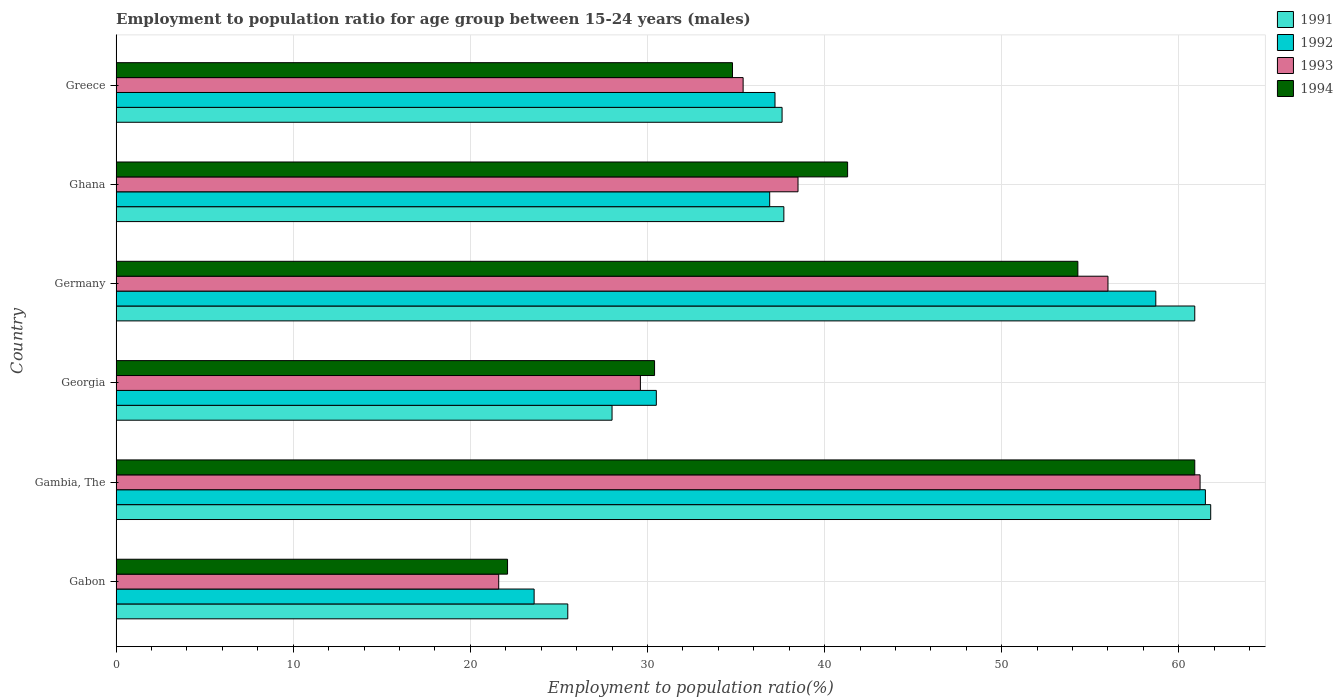How many different coloured bars are there?
Make the answer very short. 4. Are the number of bars per tick equal to the number of legend labels?
Your answer should be compact. Yes. Are the number of bars on each tick of the Y-axis equal?
Provide a succinct answer. Yes. What is the label of the 2nd group of bars from the top?
Offer a terse response. Ghana. In how many cases, is the number of bars for a given country not equal to the number of legend labels?
Keep it short and to the point. 0. What is the employment to population ratio in 1991 in Ghana?
Give a very brief answer. 37.7. Across all countries, what is the maximum employment to population ratio in 1991?
Ensure brevity in your answer.  61.8. Across all countries, what is the minimum employment to population ratio in 1991?
Provide a succinct answer. 25.5. In which country was the employment to population ratio in 1993 maximum?
Your answer should be very brief. Gambia, The. In which country was the employment to population ratio in 1992 minimum?
Provide a succinct answer. Gabon. What is the total employment to population ratio in 1994 in the graph?
Keep it short and to the point. 243.8. What is the difference between the employment to population ratio in 1994 in Gambia, The and that in Germany?
Provide a succinct answer. 6.6. What is the difference between the employment to population ratio in 1992 in Gambia, The and the employment to population ratio in 1994 in Gabon?
Keep it short and to the point. 39.4. What is the average employment to population ratio in 1994 per country?
Give a very brief answer. 40.63. What is the difference between the employment to population ratio in 1991 and employment to population ratio in 1993 in Germany?
Provide a succinct answer. 4.9. In how many countries, is the employment to population ratio in 1992 greater than 44 %?
Your response must be concise. 2. What is the ratio of the employment to population ratio in 1992 in Gabon to that in Gambia, The?
Offer a very short reply. 0.38. Is the difference between the employment to population ratio in 1991 in Gambia, The and Greece greater than the difference between the employment to population ratio in 1993 in Gambia, The and Greece?
Provide a short and direct response. No. What is the difference between the highest and the second highest employment to population ratio in 1991?
Offer a terse response. 0.9. What is the difference between the highest and the lowest employment to population ratio in 1992?
Your answer should be very brief. 37.9. Is it the case that in every country, the sum of the employment to population ratio in 1991 and employment to population ratio in 1994 is greater than the sum of employment to population ratio in 1992 and employment to population ratio in 1993?
Keep it short and to the point. No. How many countries are there in the graph?
Ensure brevity in your answer.  6. What is the difference between two consecutive major ticks on the X-axis?
Your answer should be compact. 10. Are the values on the major ticks of X-axis written in scientific E-notation?
Your response must be concise. No. Does the graph contain any zero values?
Offer a very short reply. No. What is the title of the graph?
Your response must be concise. Employment to population ratio for age group between 15-24 years (males). Does "1997" appear as one of the legend labels in the graph?
Keep it short and to the point. No. What is the label or title of the Y-axis?
Provide a short and direct response. Country. What is the Employment to population ratio(%) of 1992 in Gabon?
Ensure brevity in your answer.  23.6. What is the Employment to population ratio(%) of 1993 in Gabon?
Offer a very short reply. 21.6. What is the Employment to population ratio(%) of 1994 in Gabon?
Provide a short and direct response. 22.1. What is the Employment to population ratio(%) of 1991 in Gambia, The?
Offer a very short reply. 61.8. What is the Employment to population ratio(%) of 1992 in Gambia, The?
Offer a terse response. 61.5. What is the Employment to population ratio(%) in 1993 in Gambia, The?
Your answer should be very brief. 61.2. What is the Employment to population ratio(%) of 1994 in Gambia, The?
Keep it short and to the point. 60.9. What is the Employment to population ratio(%) of 1991 in Georgia?
Give a very brief answer. 28. What is the Employment to population ratio(%) in 1992 in Georgia?
Give a very brief answer. 30.5. What is the Employment to population ratio(%) of 1993 in Georgia?
Give a very brief answer. 29.6. What is the Employment to population ratio(%) of 1994 in Georgia?
Keep it short and to the point. 30.4. What is the Employment to population ratio(%) in 1991 in Germany?
Ensure brevity in your answer.  60.9. What is the Employment to population ratio(%) in 1992 in Germany?
Your response must be concise. 58.7. What is the Employment to population ratio(%) of 1993 in Germany?
Your answer should be very brief. 56. What is the Employment to population ratio(%) in 1994 in Germany?
Offer a very short reply. 54.3. What is the Employment to population ratio(%) of 1991 in Ghana?
Provide a succinct answer. 37.7. What is the Employment to population ratio(%) of 1992 in Ghana?
Your answer should be compact. 36.9. What is the Employment to population ratio(%) of 1993 in Ghana?
Offer a very short reply. 38.5. What is the Employment to population ratio(%) in 1994 in Ghana?
Keep it short and to the point. 41.3. What is the Employment to population ratio(%) in 1991 in Greece?
Your answer should be compact. 37.6. What is the Employment to population ratio(%) of 1992 in Greece?
Your response must be concise. 37.2. What is the Employment to population ratio(%) in 1993 in Greece?
Give a very brief answer. 35.4. What is the Employment to population ratio(%) in 1994 in Greece?
Ensure brevity in your answer.  34.8. Across all countries, what is the maximum Employment to population ratio(%) of 1991?
Make the answer very short. 61.8. Across all countries, what is the maximum Employment to population ratio(%) in 1992?
Give a very brief answer. 61.5. Across all countries, what is the maximum Employment to population ratio(%) of 1993?
Ensure brevity in your answer.  61.2. Across all countries, what is the maximum Employment to population ratio(%) of 1994?
Provide a succinct answer. 60.9. Across all countries, what is the minimum Employment to population ratio(%) in 1991?
Give a very brief answer. 25.5. Across all countries, what is the minimum Employment to population ratio(%) in 1992?
Your answer should be very brief. 23.6. Across all countries, what is the minimum Employment to population ratio(%) in 1993?
Provide a succinct answer. 21.6. Across all countries, what is the minimum Employment to population ratio(%) in 1994?
Your answer should be compact. 22.1. What is the total Employment to population ratio(%) in 1991 in the graph?
Give a very brief answer. 251.5. What is the total Employment to population ratio(%) in 1992 in the graph?
Ensure brevity in your answer.  248.4. What is the total Employment to population ratio(%) in 1993 in the graph?
Make the answer very short. 242.3. What is the total Employment to population ratio(%) of 1994 in the graph?
Your response must be concise. 243.8. What is the difference between the Employment to population ratio(%) in 1991 in Gabon and that in Gambia, The?
Provide a succinct answer. -36.3. What is the difference between the Employment to population ratio(%) of 1992 in Gabon and that in Gambia, The?
Provide a short and direct response. -37.9. What is the difference between the Employment to population ratio(%) in 1993 in Gabon and that in Gambia, The?
Provide a succinct answer. -39.6. What is the difference between the Employment to population ratio(%) in 1994 in Gabon and that in Gambia, The?
Give a very brief answer. -38.8. What is the difference between the Employment to population ratio(%) in 1991 in Gabon and that in Georgia?
Provide a succinct answer. -2.5. What is the difference between the Employment to population ratio(%) of 1992 in Gabon and that in Georgia?
Offer a terse response. -6.9. What is the difference between the Employment to population ratio(%) of 1994 in Gabon and that in Georgia?
Provide a succinct answer. -8.3. What is the difference between the Employment to population ratio(%) in 1991 in Gabon and that in Germany?
Your answer should be compact. -35.4. What is the difference between the Employment to population ratio(%) of 1992 in Gabon and that in Germany?
Ensure brevity in your answer.  -35.1. What is the difference between the Employment to population ratio(%) in 1993 in Gabon and that in Germany?
Keep it short and to the point. -34.4. What is the difference between the Employment to population ratio(%) of 1994 in Gabon and that in Germany?
Provide a succinct answer. -32.2. What is the difference between the Employment to population ratio(%) of 1991 in Gabon and that in Ghana?
Give a very brief answer. -12.2. What is the difference between the Employment to population ratio(%) in 1992 in Gabon and that in Ghana?
Ensure brevity in your answer.  -13.3. What is the difference between the Employment to population ratio(%) of 1993 in Gabon and that in Ghana?
Offer a terse response. -16.9. What is the difference between the Employment to population ratio(%) in 1994 in Gabon and that in Ghana?
Provide a short and direct response. -19.2. What is the difference between the Employment to population ratio(%) of 1991 in Gabon and that in Greece?
Offer a very short reply. -12.1. What is the difference between the Employment to population ratio(%) in 1993 in Gabon and that in Greece?
Offer a very short reply. -13.8. What is the difference between the Employment to population ratio(%) in 1991 in Gambia, The and that in Georgia?
Offer a terse response. 33.8. What is the difference between the Employment to population ratio(%) in 1992 in Gambia, The and that in Georgia?
Your answer should be compact. 31. What is the difference between the Employment to population ratio(%) of 1993 in Gambia, The and that in Georgia?
Provide a succinct answer. 31.6. What is the difference between the Employment to population ratio(%) in 1994 in Gambia, The and that in Georgia?
Your answer should be compact. 30.5. What is the difference between the Employment to population ratio(%) of 1991 in Gambia, The and that in Ghana?
Offer a very short reply. 24.1. What is the difference between the Employment to population ratio(%) in 1992 in Gambia, The and that in Ghana?
Give a very brief answer. 24.6. What is the difference between the Employment to population ratio(%) of 1993 in Gambia, The and that in Ghana?
Give a very brief answer. 22.7. What is the difference between the Employment to population ratio(%) of 1994 in Gambia, The and that in Ghana?
Offer a terse response. 19.6. What is the difference between the Employment to population ratio(%) in 1991 in Gambia, The and that in Greece?
Provide a succinct answer. 24.2. What is the difference between the Employment to population ratio(%) of 1992 in Gambia, The and that in Greece?
Your answer should be very brief. 24.3. What is the difference between the Employment to population ratio(%) in 1993 in Gambia, The and that in Greece?
Ensure brevity in your answer.  25.8. What is the difference between the Employment to population ratio(%) in 1994 in Gambia, The and that in Greece?
Offer a very short reply. 26.1. What is the difference between the Employment to population ratio(%) in 1991 in Georgia and that in Germany?
Provide a succinct answer. -32.9. What is the difference between the Employment to population ratio(%) of 1992 in Georgia and that in Germany?
Offer a terse response. -28.2. What is the difference between the Employment to population ratio(%) of 1993 in Georgia and that in Germany?
Your response must be concise. -26.4. What is the difference between the Employment to population ratio(%) in 1994 in Georgia and that in Germany?
Make the answer very short. -23.9. What is the difference between the Employment to population ratio(%) of 1992 in Georgia and that in Ghana?
Offer a very short reply. -6.4. What is the difference between the Employment to population ratio(%) in 1993 in Georgia and that in Ghana?
Your response must be concise. -8.9. What is the difference between the Employment to population ratio(%) of 1991 in Georgia and that in Greece?
Keep it short and to the point. -9.6. What is the difference between the Employment to population ratio(%) of 1993 in Georgia and that in Greece?
Provide a succinct answer. -5.8. What is the difference between the Employment to population ratio(%) of 1994 in Georgia and that in Greece?
Your answer should be compact. -4.4. What is the difference between the Employment to population ratio(%) in 1991 in Germany and that in Ghana?
Your response must be concise. 23.2. What is the difference between the Employment to population ratio(%) in 1992 in Germany and that in Ghana?
Make the answer very short. 21.8. What is the difference between the Employment to population ratio(%) of 1993 in Germany and that in Ghana?
Your answer should be very brief. 17.5. What is the difference between the Employment to population ratio(%) of 1994 in Germany and that in Ghana?
Offer a very short reply. 13. What is the difference between the Employment to population ratio(%) in 1991 in Germany and that in Greece?
Your answer should be very brief. 23.3. What is the difference between the Employment to population ratio(%) of 1993 in Germany and that in Greece?
Offer a terse response. 20.6. What is the difference between the Employment to population ratio(%) in 1994 in Germany and that in Greece?
Offer a very short reply. 19.5. What is the difference between the Employment to population ratio(%) in 1991 in Ghana and that in Greece?
Give a very brief answer. 0.1. What is the difference between the Employment to population ratio(%) of 1992 in Ghana and that in Greece?
Provide a short and direct response. -0.3. What is the difference between the Employment to population ratio(%) in 1994 in Ghana and that in Greece?
Offer a very short reply. 6.5. What is the difference between the Employment to population ratio(%) of 1991 in Gabon and the Employment to population ratio(%) of 1992 in Gambia, The?
Your answer should be compact. -36. What is the difference between the Employment to population ratio(%) of 1991 in Gabon and the Employment to population ratio(%) of 1993 in Gambia, The?
Keep it short and to the point. -35.7. What is the difference between the Employment to population ratio(%) in 1991 in Gabon and the Employment to population ratio(%) in 1994 in Gambia, The?
Offer a terse response. -35.4. What is the difference between the Employment to population ratio(%) in 1992 in Gabon and the Employment to population ratio(%) in 1993 in Gambia, The?
Give a very brief answer. -37.6. What is the difference between the Employment to population ratio(%) in 1992 in Gabon and the Employment to population ratio(%) in 1994 in Gambia, The?
Keep it short and to the point. -37.3. What is the difference between the Employment to population ratio(%) of 1993 in Gabon and the Employment to population ratio(%) of 1994 in Gambia, The?
Make the answer very short. -39.3. What is the difference between the Employment to population ratio(%) in 1992 in Gabon and the Employment to population ratio(%) in 1994 in Georgia?
Keep it short and to the point. -6.8. What is the difference between the Employment to population ratio(%) of 1993 in Gabon and the Employment to population ratio(%) of 1994 in Georgia?
Your response must be concise. -8.8. What is the difference between the Employment to population ratio(%) in 1991 in Gabon and the Employment to population ratio(%) in 1992 in Germany?
Offer a very short reply. -33.2. What is the difference between the Employment to population ratio(%) in 1991 in Gabon and the Employment to population ratio(%) in 1993 in Germany?
Offer a terse response. -30.5. What is the difference between the Employment to population ratio(%) in 1991 in Gabon and the Employment to population ratio(%) in 1994 in Germany?
Provide a succinct answer. -28.8. What is the difference between the Employment to population ratio(%) in 1992 in Gabon and the Employment to population ratio(%) in 1993 in Germany?
Your response must be concise. -32.4. What is the difference between the Employment to population ratio(%) of 1992 in Gabon and the Employment to population ratio(%) of 1994 in Germany?
Offer a very short reply. -30.7. What is the difference between the Employment to population ratio(%) in 1993 in Gabon and the Employment to population ratio(%) in 1994 in Germany?
Offer a terse response. -32.7. What is the difference between the Employment to population ratio(%) of 1991 in Gabon and the Employment to population ratio(%) of 1993 in Ghana?
Your answer should be very brief. -13. What is the difference between the Employment to population ratio(%) in 1991 in Gabon and the Employment to population ratio(%) in 1994 in Ghana?
Ensure brevity in your answer.  -15.8. What is the difference between the Employment to population ratio(%) of 1992 in Gabon and the Employment to population ratio(%) of 1993 in Ghana?
Provide a short and direct response. -14.9. What is the difference between the Employment to population ratio(%) of 1992 in Gabon and the Employment to population ratio(%) of 1994 in Ghana?
Offer a terse response. -17.7. What is the difference between the Employment to population ratio(%) of 1993 in Gabon and the Employment to population ratio(%) of 1994 in Ghana?
Offer a very short reply. -19.7. What is the difference between the Employment to population ratio(%) in 1991 in Gabon and the Employment to population ratio(%) in 1992 in Greece?
Offer a very short reply. -11.7. What is the difference between the Employment to population ratio(%) in 1992 in Gabon and the Employment to population ratio(%) in 1993 in Greece?
Provide a succinct answer. -11.8. What is the difference between the Employment to population ratio(%) of 1992 in Gabon and the Employment to population ratio(%) of 1994 in Greece?
Make the answer very short. -11.2. What is the difference between the Employment to population ratio(%) of 1993 in Gabon and the Employment to population ratio(%) of 1994 in Greece?
Offer a very short reply. -13.2. What is the difference between the Employment to population ratio(%) in 1991 in Gambia, The and the Employment to population ratio(%) in 1992 in Georgia?
Offer a very short reply. 31.3. What is the difference between the Employment to population ratio(%) of 1991 in Gambia, The and the Employment to population ratio(%) of 1993 in Georgia?
Offer a terse response. 32.2. What is the difference between the Employment to population ratio(%) in 1991 in Gambia, The and the Employment to population ratio(%) in 1994 in Georgia?
Offer a very short reply. 31.4. What is the difference between the Employment to population ratio(%) in 1992 in Gambia, The and the Employment to population ratio(%) in 1993 in Georgia?
Ensure brevity in your answer.  31.9. What is the difference between the Employment to population ratio(%) of 1992 in Gambia, The and the Employment to population ratio(%) of 1994 in Georgia?
Your answer should be very brief. 31.1. What is the difference between the Employment to population ratio(%) of 1993 in Gambia, The and the Employment to population ratio(%) of 1994 in Georgia?
Provide a short and direct response. 30.8. What is the difference between the Employment to population ratio(%) of 1992 in Gambia, The and the Employment to population ratio(%) of 1994 in Germany?
Your answer should be compact. 7.2. What is the difference between the Employment to population ratio(%) of 1993 in Gambia, The and the Employment to population ratio(%) of 1994 in Germany?
Make the answer very short. 6.9. What is the difference between the Employment to population ratio(%) of 1991 in Gambia, The and the Employment to population ratio(%) of 1992 in Ghana?
Your answer should be compact. 24.9. What is the difference between the Employment to population ratio(%) of 1991 in Gambia, The and the Employment to population ratio(%) of 1993 in Ghana?
Ensure brevity in your answer.  23.3. What is the difference between the Employment to population ratio(%) in 1991 in Gambia, The and the Employment to population ratio(%) in 1994 in Ghana?
Make the answer very short. 20.5. What is the difference between the Employment to population ratio(%) in 1992 in Gambia, The and the Employment to population ratio(%) in 1993 in Ghana?
Give a very brief answer. 23. What is the difference between the Employment to population ratio(%) of 1992 in Gambia, The and the Employment to population ratio(%) of 1994 in Ghana?
Offer a terse response. 20.2. What is the difference between the Employment to population ratio(%) of 1991 in Gambia, The and the Employment to population ratio(%) of 1992 in Greece?
Offer a terse response. 24.6. What is the difference between the Employment to population ratio(%) of 1991 in Gambia, The and the Employment to population ratio(%) of 1993 in Greece?
Keep it short and to the point. 26.4. What is the difference between the Employment to population ratio(%) in 1991 in Gambia, The and the Employment to population ratio(%) in 1994 in Greece?
Your response must be concise. 27. What is the difference between the Employment to population ratio(%) of 1992 in Gambia, The and the Employment to population ratio(%) of 1993 in Greece?
Provide a short and direct response. 26.1. What is the difference between the Employment to population ratio(%) in 1992 in Gambia, The and the Employment to population ratio(%) in 1994 in Greece?
Your answer should be very brief. 26.7. What is the difference between the Employment to population ratio(%) in 1993 in Gambia, The and the Employment to population ratio(%) in 1994 in Greece?
Provide a succinct answer. 26.4. What is the difference between the Employment to population ratio(%) of 1991 in Georgia and the Employment to population ratio(%) of 1992 in Germany?
Make the answer very short. -30.7. What is the difference between the Employment to population ratio(%) in 1991 in Georgia and the Employment to population ratio(%) in 1993 in Germany?
Your answer should be very brief. -28. What is the difference between the Employment to population ratio(%) in 1991 in Georgia and the Employment to population ratio(%) in 1994 in Germany?
Keep it short and to the point. -26.3. What is the difference between the Employment to population ratio(%) in 1992 in Georgia and the Employment to population ratio(%) in 1993 in Germany?
Make the answer very short. -25.5. What is the difference between the Employment to population ratio(%) of 1992 in Georgia and the Employment to population ratio(%) of 1994 in Germany?
Offer a terse response. -23.8. What is the difference between the Employment to population ratio(%) in 1993 in Georgia and the Employment to population ratio(%) in 1994 in Germany?
Offer a very short reply. -24.7. What is the difference between the Employment to population ratio(%) of 1991 in Georgia and the Employment to population ratio(%) of 1992 in Ghana?
Offer a very short reply. -8.9. What is the difference between the Employment to population ratio(%) in 1991 in Georgia and the Employment to population ratio(%) in 1993 in Ghana?
Keep it short and to the point. -10.5. What is the difference between the Employment to population ratio(%) in 1993 in Georgia and the Employment to population ratio(%) in 1994 in Ghana?
Your answer should be very brief. -11.7. What is the difference between the Employment to population ratio(%) of 1991 in Georgia and the Employment to population ratio(%) of 1992 in Greece?
Provide a short and direct response. -9.2. What is the difference between the Employment to population ratio(%) in 1991 in Georgia and the Employment to population ratio(%) in 1994 in Greece?
Your answer should be very brief. -6.8. What is the difference between the Employment to population ratio(%) of 1992 in Georgia and the Employment to population ratio(%) of 1993 in Greece?
Offer a terse response. -4.9. What is the difference between the Employment to population ratio(%) of 1992 in Georgia and the Employment to population ratio(%) of 1994 in Greece?
Your answer should be compact. -4.3. What is the difference between the Employment to population ratio(%) in 1993 in Georgia and the Employment to population ratio(%) in 1994 in Greece?
Your response must be concise. -5.2. What is the difference between the Employment to population ratio(%) of 1991 in Germany and the Employment to population ratio(%) of 1993 in Ghana?
Make the answer very short. 22.4. What is the difference between the Employment to population ratio(%) in 1991 in Germany and the Employment to population ratio(%) in 1994 in Ghana?
Offer a very short reply. 19.6. What is the difference between the Employment to population ratio(%) of 1992 in Germany and the Employment to population ratio(%) of 1993 in Ghana?
Give a very brief answer. 20.2. What is the difference between the Employment to population ratio(%) of 1993 in Germany and the Employment to population ratio(%) of 1994 in Ghana?
Keep it short and to the point. 14.7. What is the difference between the Employment to population ratio(%) in 1991 in Germany and the Employment to population ratio(%) in 1992 in Greece?
Offer a terse response. 23.7. What is the difference between the Employment to population ratio(%) of 1991 in Germany and the Employment to population ratio(%) of 1993 in Greece?
Offer a terse response. 25.5. What is the difference between the Employment to population ratio(%) of 1991 in Germany and the Employment to population ratio(%) of 1994 in Greece?
Offer a terse response. 26.1. What is the difference between the Employment to population ratio(%) of 1992 in Germany and the Employment to population ratio(%) of 1993 in Greece?
Make the answer very short. 23.3. What is the difference between the Employment to population ratio(%) in 1992 in Germany and the Employment to population ratio(%) in 1994 in Greece?
Offer a terse response. 23.9. What is the difference between the Employment to population ratio(%) of 1993 in Germany and the Employment to population ratio(%) of 1994 in Greece?
Make the answer very short. 21.2. What is the difference between the Employment to population ratio(%) in 1991 in Ghana and the Employment to population ratio(%) in 1992 in Greece?
Ensure brevity in your answer.  0.5. What is the difference between the Employment to population ratio(%) of 1991 in Ghana and the Employment to population ratio(%) of 1993 in Greece?
Your response must be concise. 2.3. What is the difference between the Employment to population ratio(%) of 1992 in Ghana and the Employment to population ratio(%) of 1993 in Greece?
Provide a short and direct response. 1.5. What is the difference between the Employment to population ratio(%) of 1992 in Ghana and the Employment to population ratio(%) of 1994 in Greece?
Provide a succinct answer. 2.1. What is the difference between the Employment to population ratio(%) of 1993 in Ghana and the Employment to population ratio(%) of 1994 in Greece?
Ensure brevity in your answer.  3.7. What is the average Employment to population ratio(%) of 1991 per country?
Offer a very short reply. 41.92. What is the average Employment to population ratio(%) in 1992 per country?
Offer a terse response. 41.4. What is the average Employment to population ratio(%) of 1993 per country?
Provide a succinct answer. 40.38. What is the average Employment to population ratio(%) of 1994 per country?
Offer a terse response. 40.63. What is the difference between the Employment to population ratio(%) of 1991 and Employment to population ratio(%) of 1992 in Gabon?
Your answer should be compact. 1.9. What is the difference between the Employment to population ratio(%) of 1993 and Employment to population ratio(%) of 1994 in Gabon?
Your answer should be compact. -0.5. What is the difference between the Employment to population ratio(%) of 1991 and Employment to population ratio(%) of 1994 in Gambia, The?
Give a very brief answer. 0.9. What is the difference between the Employment to population ratio(%) of 1991 and Employment to population ratio(%) of 1992 in Georgia?
Offer a very short reply. -2.5. What is the difference between the Employment to population ratio(%) of 1992 and Employment to population ratio(%) of 1993 in Georgia?
Your answer should be very brief. 0.9. What is the difference between the Employment to population ratio(%) in 1992 and Employment to population ratio(%) in 1994 in Georgia?
Provide a succinct answer. 0.1. What is the difference between the Employment to population ratio(%) of 1991 and Employment to population ratio(%) of 1994 in Germany?
Your answer should be very brief. 6.6. What is the difference between the Employment to population ratio(%) in 1991 and Employment to population ratio(%) in 1992 in Ghana?
Provide a short and direct response. 0.8. What is the difference between the Employment to population ratio(%) of 1991 and Employment to population ratio(%) of 1993 in Ghana?
Offer a terse response. -0.8. What is the difference between the Employment to population ratio(%) in 1991 and Employment to population ratio(%) in 1994 in Ghana?
Offer a terse response. -3.6. What is the difference between the Employment to population ratio(%) in 1992 and Employment to population ratio(%) in 1993 in Ghana?
Offer a terse response. -1.6. What is the difference between the Employment to population ratio(%) in 1992 and Employment to population ratio(%) in 1994 in Ghana?
Ensure brevity in your answer.  -4.4. What is the difference between the Employment to population ratio(%) in 1991 and Employment to population ratio(%) in 1992 in Greece?
Offer a terse response. 0.4. What is the difference between the Employment to population ratio(%) in 1993 and Employment to population ratio(%) in 1994 in Greece?
Your answer should be compact. 0.6. What is the ratio of the Employment to population ratio(%) in 1991 in Gabon to that in Gambia, The?
Ensure brevity in your answer.  0.41. What is the ratio of the Employment to population ratio(%) of 1992 in Gabon to that in Gambia, The?
Provide a short and direct response. 0.38. What is the ratio of the Employment to population ratio(%) of 1993 in Gabon to that in Gambia, The?
Your answer should be very brief. 0.35. What is the ratio of the Employment to population ratio(%) of 1994 in Gabon to that in Gambia, The?
Your response must be concise. 0.36. What is the ratio of the Employment to population ratio(%) in 1991 in Gabon to that in Georgia?
Ensure brevity in your answer.  0.91. What is the ratio of the Employment to population ratio(%) of 1992 in Gabon to that in Georgia?
Offer a very short reply. 0.77. What is the ratio of the Employment to population ratio(%) in 1993 in Gabon to that in Georgia?
Your answer should be compact. 0.73. What is the ratio of the Employment to population ratio(%) of 1994 in Gabon to that in Georgia?
Your response must be concise. 0.73. What is the ratio of the Employment to population ratio(%) in 1991 in Gabon to that in Germany?
Offer a terse response. 0.42. What is the ratio of the Employment to population ratio(%) in 1992 in Gabon to that in Germany?
Provide a succinct answer. 0.4. What is the ratio of the Employment to population ratio(%) of 1993 in Gabon to that in Germany?
Your answer should be compact. 0.39. What is the ratio of the Employment to population ratio(%) in 1994 in Gabon to that in Germany?
Provide a succinct answer. 0.41. What is the ratio of the Employment to population ratio(%) in 1991 in Gabon to that in Ghana?
Provide a short and direct response. 0.68. What is the ratio of the Employment to population ratio(%) of 1992 in Gabon to that in Ghana?
Make the answer very short. 0.64. What is the ratio of the Employment to population ratio(%) in 1993 in Gabon to that in Ghana?
Your answer should be compact. 0.56. What is the ratio of the Employment to population ratio(%) of 1994 in Gabon to that in Ghana?
Offer a terse response. 0.54. What is the ratio of the Employment to population ratio(%) in 1991 in Gabon to that in Greece?
Keep it short and to the point. 0.68. What is the ratio of the Employment to population ratio(%) of 1992 in Gabon to that in Greece?
Offer a terse response. 0.63. What is the ratio of the Employment to population ratio(%) of 1993 in Gabon to that in Greece?
Your answer should be compact. 0.61. What is the ratio of the Employment to population ratio(%) of 1994 in Gabon to that in Greece?
Give a very brief answer. 0.64. What is the ratio of the Employment to population ratio(%) in 1991 in Gambia, The to that in Georgia?
Provide a short and direct response. 2.21. What is the ratio of the Employment to population ratio(%) of 1992 in Gambia, The to that in Georgia?
Ensure brevity in your answer.  2.02. What is the ratio of the Employment to population ratio(%) in 1993 in Gambia, The to that in Georgia?
Ensure brevity in your answer.  2.07. What is the ratio of the Employment to population ratio(%) of 1994 in Gambia, The to that in Georgia?
Keep it short and to the point. 2. What is the ratio of the Employment to population ratio(%) in 1991 in Gambia, The to that in Germany?
Your answer should be very brief. 1.01. What is the ratio of the Employment to population ratio(%) of 1992 in Gambia, The to that in Germany?
Keep it short and to the point. 1.05. What is the ratio of the Employment to population ratio(%) in 1993 in Gambia, The to that in Germany?
Offer a very short reply. 1.09. What is the ratio of the Employment to population ratio(%) in 1994 in Gambia, The to that in Germany?
Your answer should be very brief. 1.12. What is the ratio of the Employment to population ratio(%) of 1991 in Gambia, The to that in Ghana?
Ensure brevity in your answer.  1.64. What is the ratio of the Employment to population ratio(%) in 1993 in Gambia, The to that in Ghana?
Keep it short and to the point. 1.59. What is the ratio of the Employment to population ratio(%) in 1994 in Gambia, The to that in Ghana?
Offer a very short reply. 1.47. What is the ratio of the Employment to population ratio(%) of 1991 in Gambia, The to that in Greece?
Offer a terse response. 1.64. What is the ratio of the Employment to population ratio(%) of 1992 in Gambia, The to that in Greece?
Your response must be concise. 1.65. What is the ratio of the Employment to population ratio(%) in 1993 in Gambia, The to that in Greece?
Offer a very short reply. 1.73. What is the ratio of the Employment to population ratio(%) of 1994 in Gambia, The to that in Greece?
Keep it short and to the point. 1.75. What is the ratio of the Employment to population ratio(%) of 1991 in Georgia to that in Germany?
Give a very brief answer. 0.46. What is the ratio of the Employment to population ratio(%) in 1992 in Georgia to that in Germany?
Your answer should be very brief. 0.52. What is the ratio of the Employment to population ratio(%) of 1993 in Georgia to that in Germany?
Make the answer very short. 0.53. What is the ratio of the Employment to population ratio(%) in 1994 in Georgia to that in Germany?
Keep it short and to the point. 0.56. What is the ratio of the Employment to population ratio(%) of 1991 in Georgia to that in Ghana?
Provide a succinct answer. 0.74. What is the ratio of the Employment to population ratio(%) of 1992 in Georgia to that in Ghana?
Offer a terse response. 0.83. What is the ratio of the Employment to population ratio(%) of 1993 in Georgia to that in Ghana?
Offer a terse response. 0.77. What is the ratio of the Employment to population ratio(%) of 1994 in Georgia to that in Ghana?
Your response must be concise. 0.74. What is the ratio of the Employment to population ratio(%) in 1991 in Georgia to that in Greece?
Give a very brief answer. 0.74. What is the ratio of the Employment to population ratio(%) of 1992 in Georgia to that in Greece?
Make the answer very short. 0.82. What is the ratio of the Employment to population ratio(%) in 1993 in Georgia to that in Greece?
Ensure brevity in your answer.  0.84. What is the ratio of the Employment to population ratio(%) of 1994 in Georgia to that in Greece?
Ensure brevity in your answer.  0.87. What is the ratio of the Employment to population ratio(%) in 1991 in Germany to that in Ghana?
Offer a very short reply. 1.62. What is the ratio of the Employment to population ratio(%) in 1992 in Germany to that in Ghana?
Provide a succinct answer. 1.59. What is the ratio of the Employment to population ratio(%) in 1993 in Germany to that in Ghana?
Offer a terse response. 1.45. What is the ratio of the Employment to population ratio(%) in 1994 in Germany to that in Ghana?
Your answer should be very brief. 1.31. What is the ratio of the Employment to population ratio(%) in 1991 in Germany to that in Greece?
Ensure brevity in your answer.  1.62. What is the ratio of the Employment to population ratio(%) in 1992 in Germany to that in Greece?
Offer a very short reply. 1.58. What is the ratio of the Employment to population ratio(%) of 1993 in Germany to that in Greece?
Offer a terse response. 1.58. What is the ratio of the Employment to population ratio(%) in 1994 in Germany to that in Greece?
Ensure brevity in your answer.  1.56. What is the ratio of the Employment to population ratio(%) in 1992 in Ghana to that in Greece?
Your response must be concise. 0.99. What is the ratio of the Employment to population ratio(%) of 1993 in Ghana to that in Greece?
Offer a very short reply. 1.09. What is the ratio of the Employment to population ratio(%) of 1994 in Ghana to that in Greece?
Your answer should be compact. 1.19. What is the difference between the highest and the second highest Employment to population ratio(%) in 1991?
Provide a short and direct response. 0.9. What is the difference between the highest and the second highest Employment to population ratio(%) of 1992?
Provide a succinct answer. 2.8. What is the difference between the highest and the second highest Employment to population ratio(%) in 1994?
Ensure brevity in your answer.  6.6. What is the difference between the highest and the lowest Employment to population ratio(%) of 1991?
Your answer should be compact. 36.3. What is the difference between the highest and the lowest Employment to population ratio(%) of 1992?
Keep it short and to the point. 37.9. What is the difference between the highest and the lowest Employment to population ratio(%) in 1993?
Offer a very short reply. 39.6. What is the difference between the highest and the lowest Employment to population ratio(%) of 1994?
Provide a succinct answer. 38.8. 